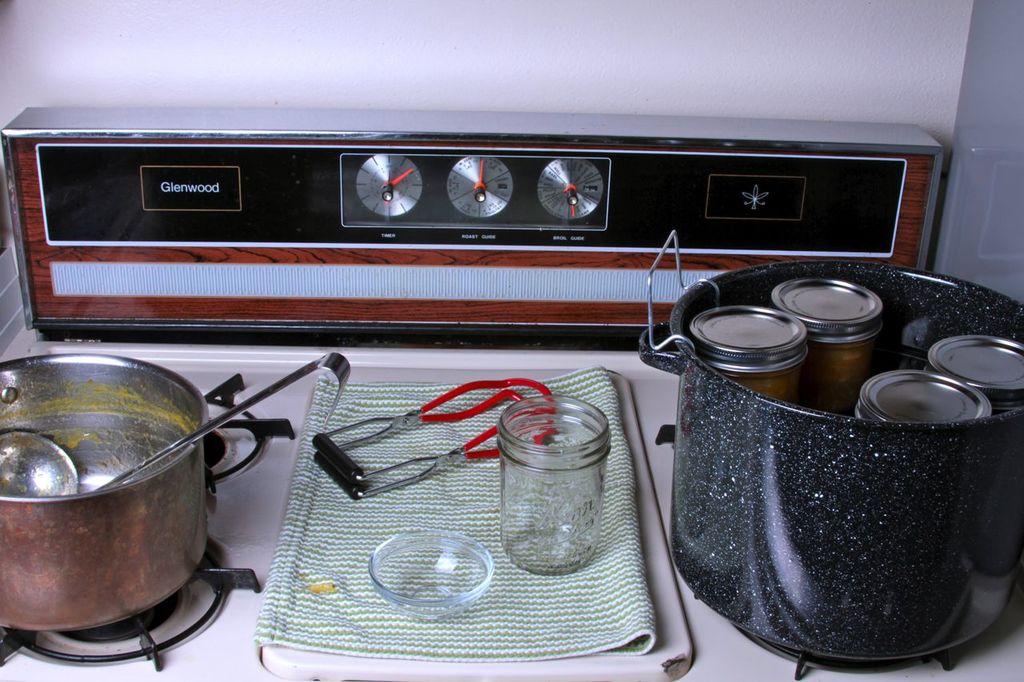What company makes this stove?
Your answer should be very brief. Glenwood. 